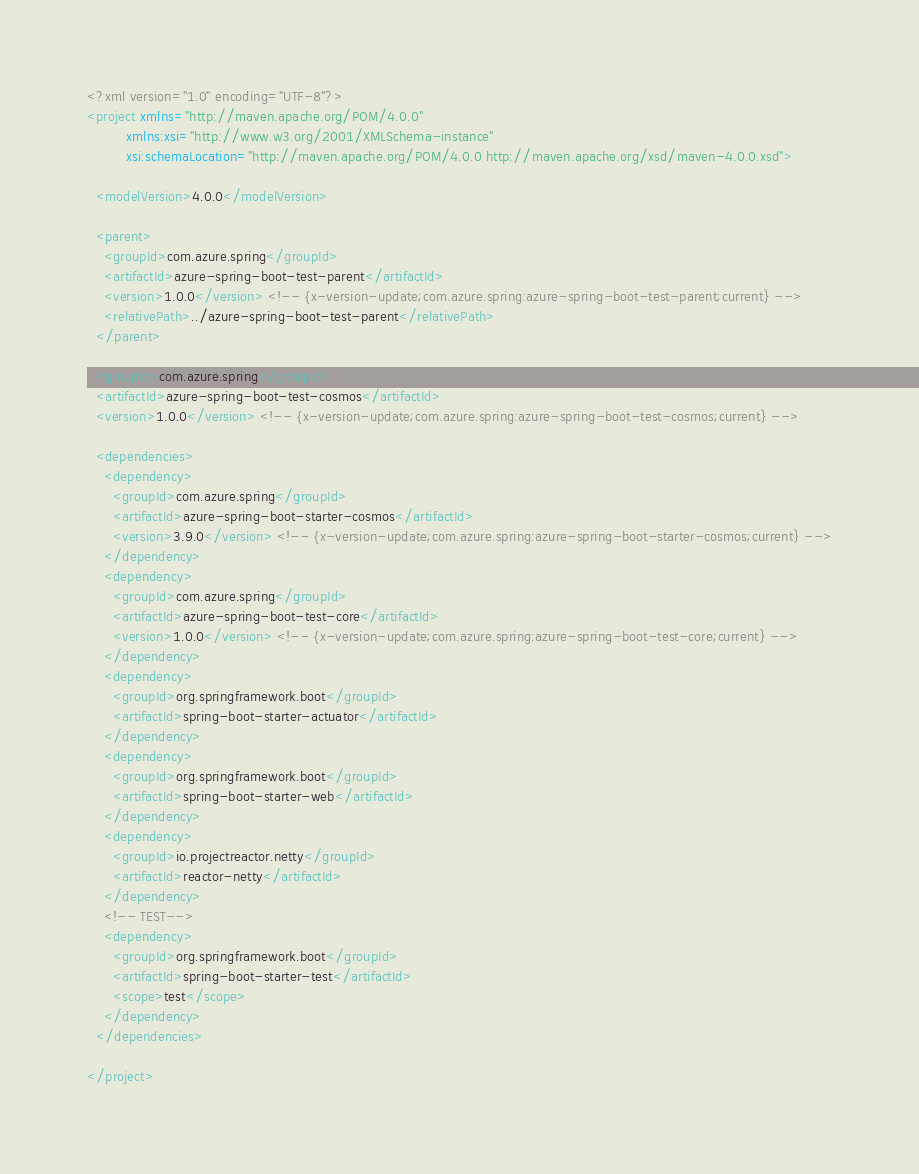<code> <loc_0><loc_0><loc_500><loc_500><_XML_><?xml version="1.0" encoding="UTF-8"?>
<project xmlns="http://maven.apache.org/POM/4.0.0"
         xmlns:xsi="http://www.w3.org/2001/XMLSchema-instance"
         xsi:schemaLocation="http://maven.apache.org/POM/4.0.0 http://maven.apache.org/xsd/maven-4.0.0.xsd">

  <modelVersion>4.0.0</modelVersion>

  <parent>
    <groupId>com.azure.spring</groupId>
    <artifactId>azure-spring-boot-test-parent</artifactId>
    <version>1.0.0</version> <!-- {x-version-update;com.azure.spring:azure-spring-boot-test-parent;current} -->
    <relativePath>../azure-spring-boot-test-parent</relativePath>
  </parent>

  <groupId>com.azure.spring</groupId>
  <artifactId>azure-spring-boot-test-cosmos</artifactId>
  <version>1.0.0</version> <!-- {x-version-update;com.azure.spring:azure-spring-boot-test-cosmos;current} -->

  <dependencies>
    <dependency>
      <groupId>com.azure.spring</groupId>
      <artifactId>azure-spring-boot-starter-cosmos</artifactId>
      <version>3.9.0</version> <!-- {x-version-update;com.azure.spring:azure-spring-boot-starter-cosmos;current} -->
    </dependency>
    <dependency>
      <groupId>com.azure.spring</groupId>
      <artifactId>azure-spring-boot-test-core</artifactId>
      <version>1.0.0</version> <!-- {x-version-update;com.azure.spring:azure-spring-boot-test-core;current} -->
    </dependency>
    <dependency>
      <groupId>org.springframework.boot</groupId>
      <artifactId>spring-boot-starter-actuator</artifactId>
    </dependency>
    <dependency>
      <groupId>org.springframework.boot</groupId>
      <artifactId>spring-boot-starter-web</artifactId>
    </dependency>
    <dependency>
      <groupId>io.projectreactor.netty</groupId>
      <artifactId>reactor-netty</artifactId>
    </dependency>
    <!-- TEST-->
    <dependency>
      <groupId>org.springframework.boot</groupId>
      <artifactId>spring-boot-starter-test</artifactId>
      <scope>test</scope>
    </dependency>
  </dependencies>

</project>
</code> 